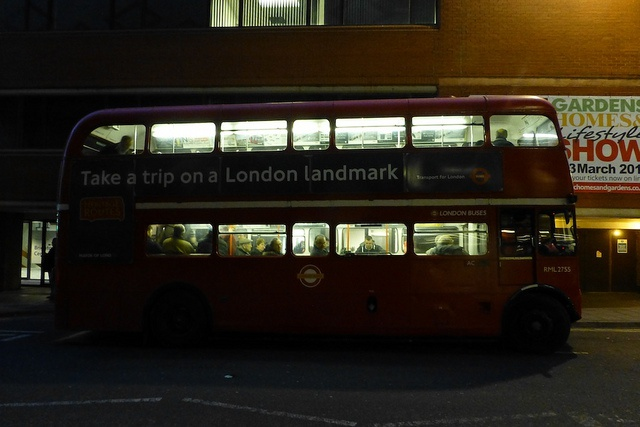Describe the objects in this image and their specific colors. I can see bus in black, ivory, and darkgreen tones, people in black, darkgreen, and olive tones, people in black, darkgreen, and olive tones, people in black and darkgreen tones, and people in black and darkgreen tones in this image. 